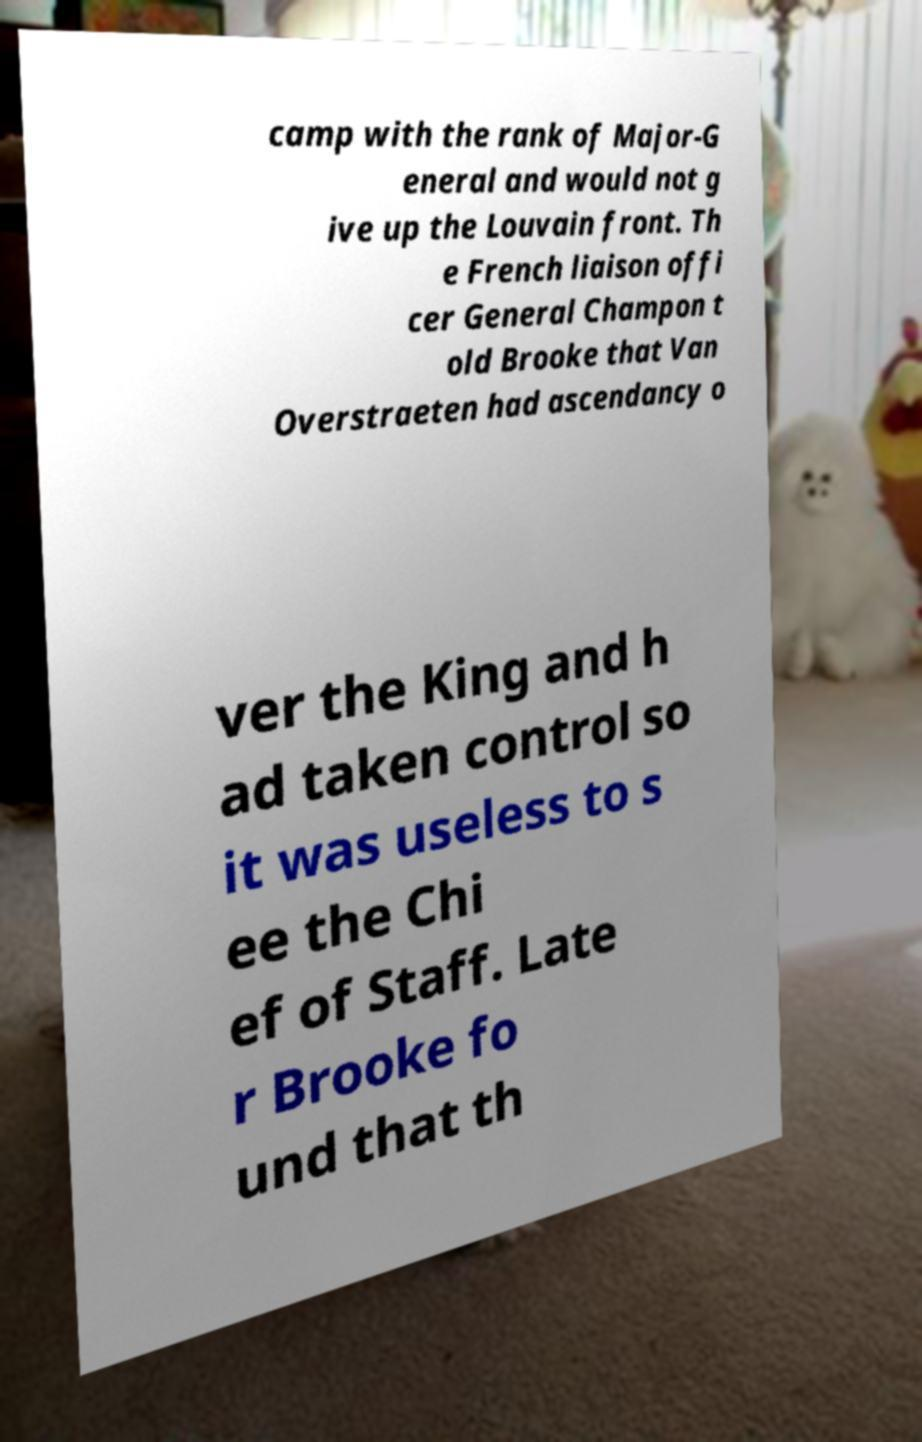Please identify and transcribe the text found in this image. camp with the rank of Major-G eneral and would not g ive up the Louvain front. Th e French liaison offi cer General Champon t old Brooke that Van Overstraeten had ascendancy o ver the King and h ad taken control so it was useless to s ee the Chi ef of Staff. Late r Brooke fo und that th 